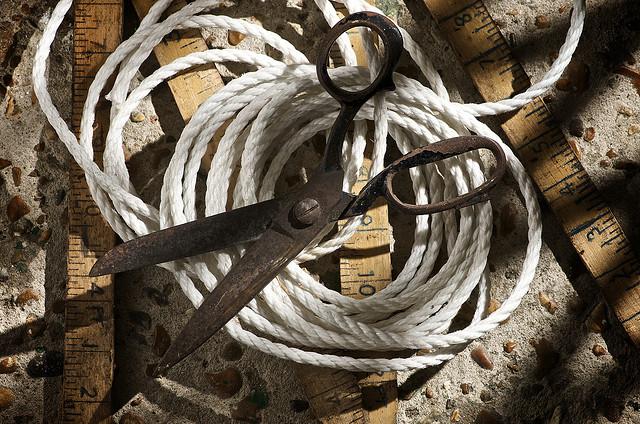What are the objects with numbers on them?
Keep it brief. Rulers. What are the scissors laying on top of?
Be succinct. Rope. Is all of the rope neatly coiled?
Write a very short answer. No. What color is the scissors?
Quick response, please. Black. Are the scissors rusty?
Keep it brief. Yes. 